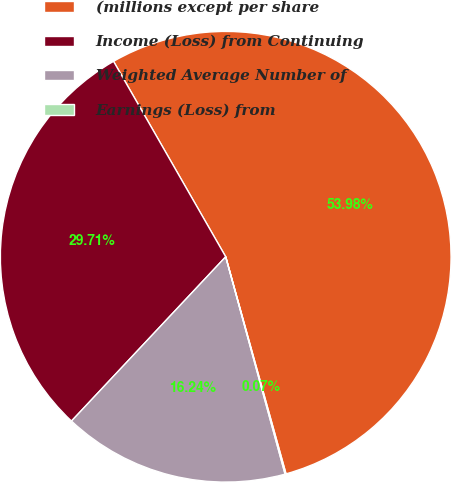<chart> <loc_0><loc_0><loc_500><loc_500><pie_chart><fcel>(millions except per share<fcel>Income (Loss) from Continuing<fcel>Weighted Average Number of<fcel>Earnings (Loss) from<nl><fcel>53.98%<fcel>29.71%<fcel>16.24%<fcel>0.07%<nl></chart> 